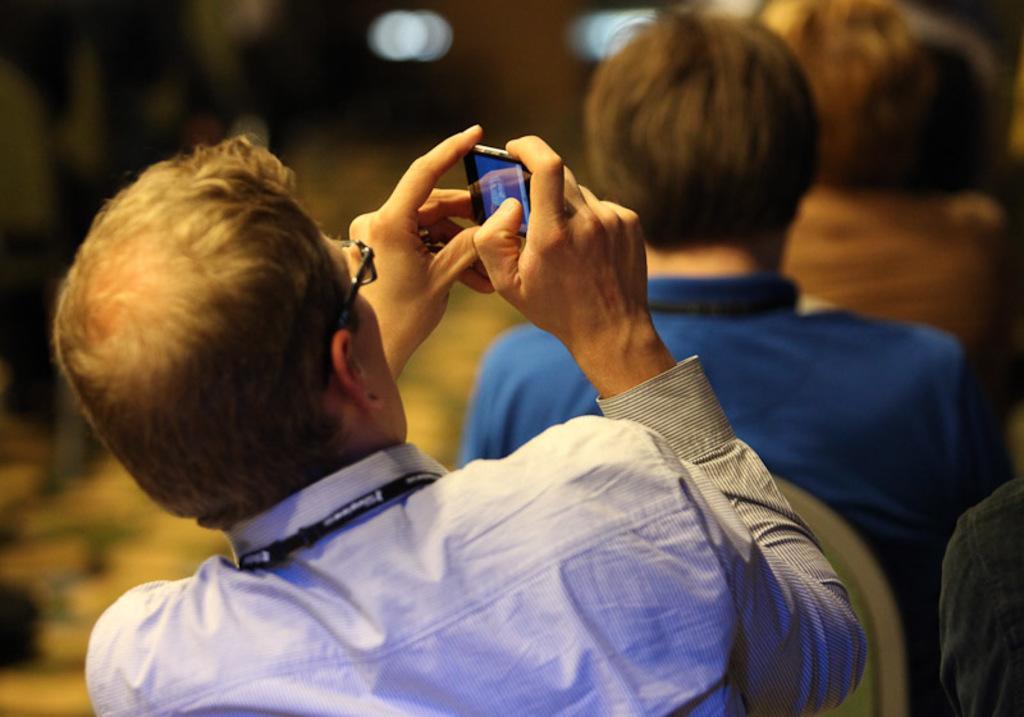Could you give a brief overview of what you see in this image? In the image there is a man in blue shirt holding a cellphone and behind him there are few other persons sitting. 